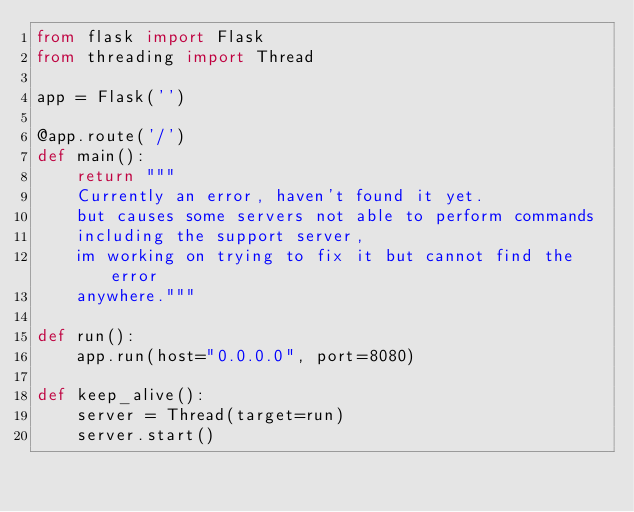Convert code to text. <code><loc_0><loc_0><loc_500><loc_500><_Python_>from flask import Flask
from threading import Thread

app = Flask('')

@app.route('/')
def main():
    return """
    Currently an error, haven't found it yet.
    but causes some servers not able to perform commands
    including the support server,
    im working on trying to fix it but cannot find the error
    anywhere."""

def run():
    app.run(host="0.0.0.0", port=8080)

def keep_alive():
    server = Thread(target=run)
    server.start()</code> 